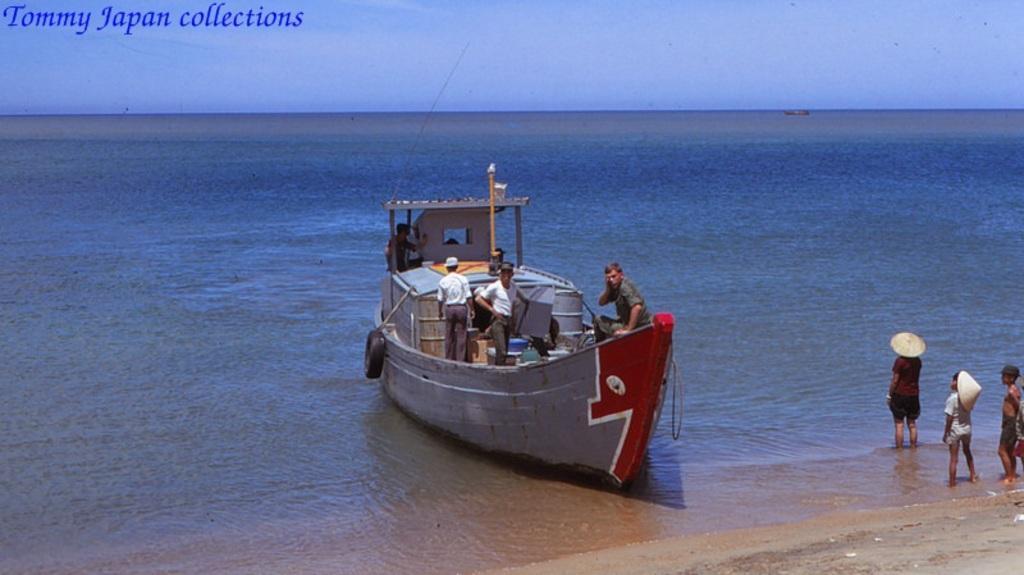Please provide a concise description of this image. In this image there is water and we can see a boat on the water. There are people in the boat. On the right there are kids wearing hats. At the top there is sky. 